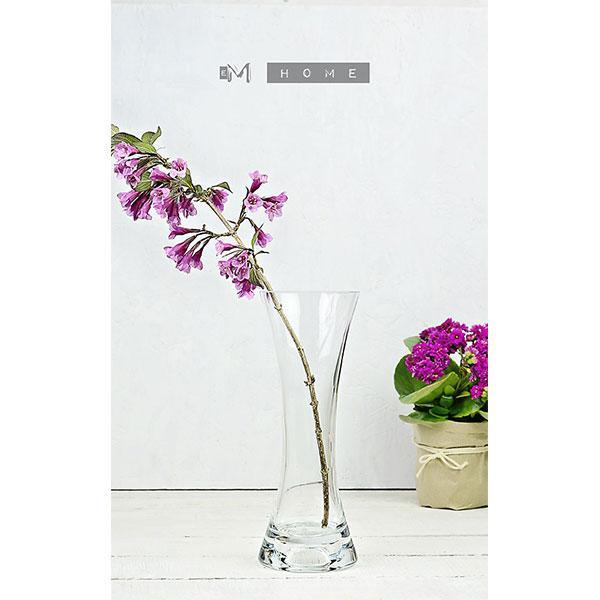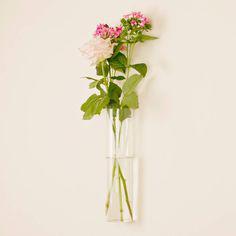The first image is the image on the left, the second image is the image on the right. Analyze the images presented: Is the assertion "The image on the left contains white flowers in a vase." valid? Answer yes or no. No. 